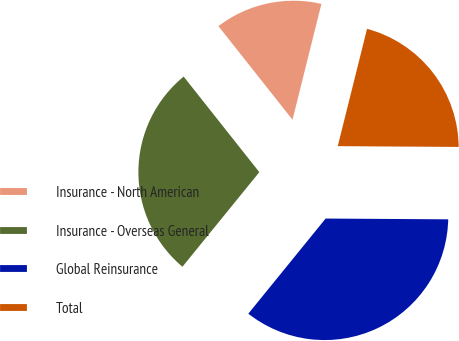Convert chart. <chart><loc_0><loc_0><loc_500><loc_500><pie_chart><fcel>Insurance - North American<fcel>Insurance - Overseas General<fcel>Global Reinsurance<fcel>Total<nl><fcel>14.55%<fcel>28.48%<fcel>35.76%<fcel>21.21%<nl></chart> 